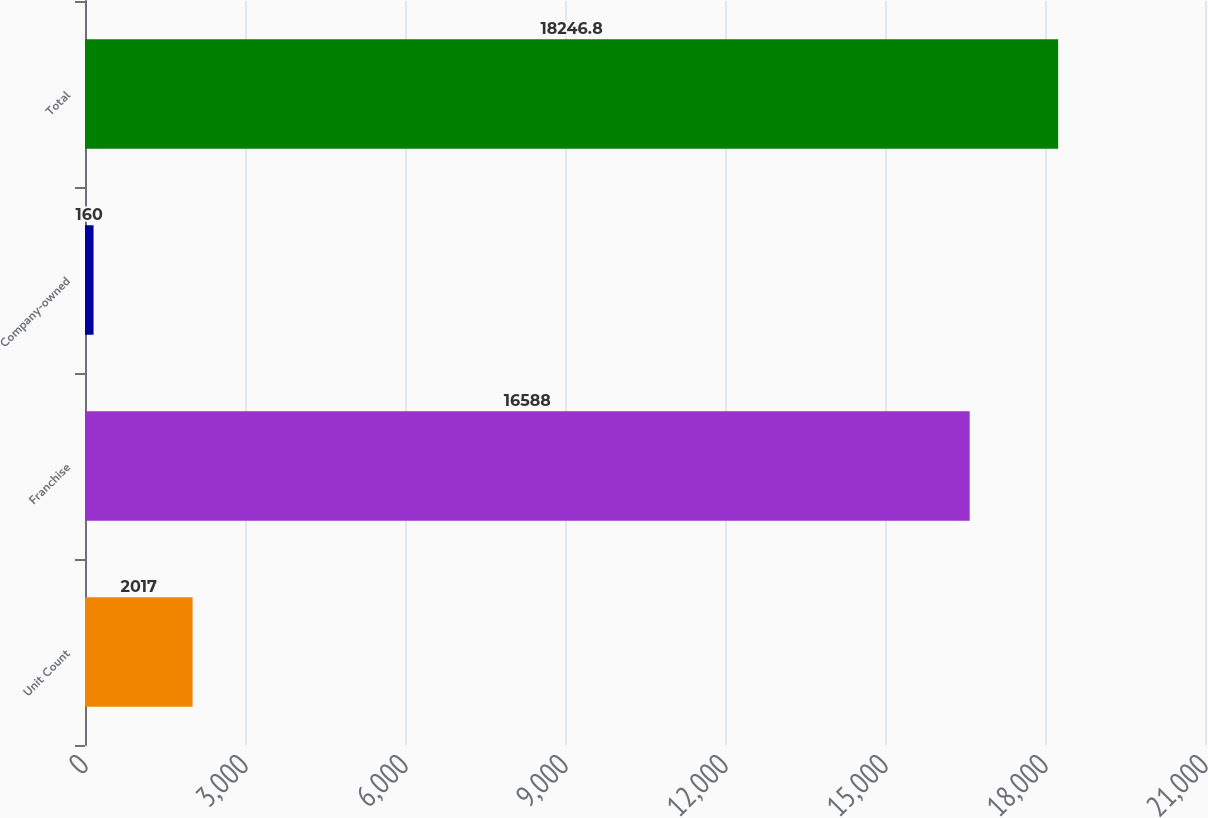<chart> <loc_0><loc_0><loc_500><loc_500><bar_chart><fcel>Unit Count<fcel>Franchise<fcel>Company-owned<fcel>Total<nl><fcel>2017<fcel>16588<fcel>160<fcel>18246.8<nl></chart> 